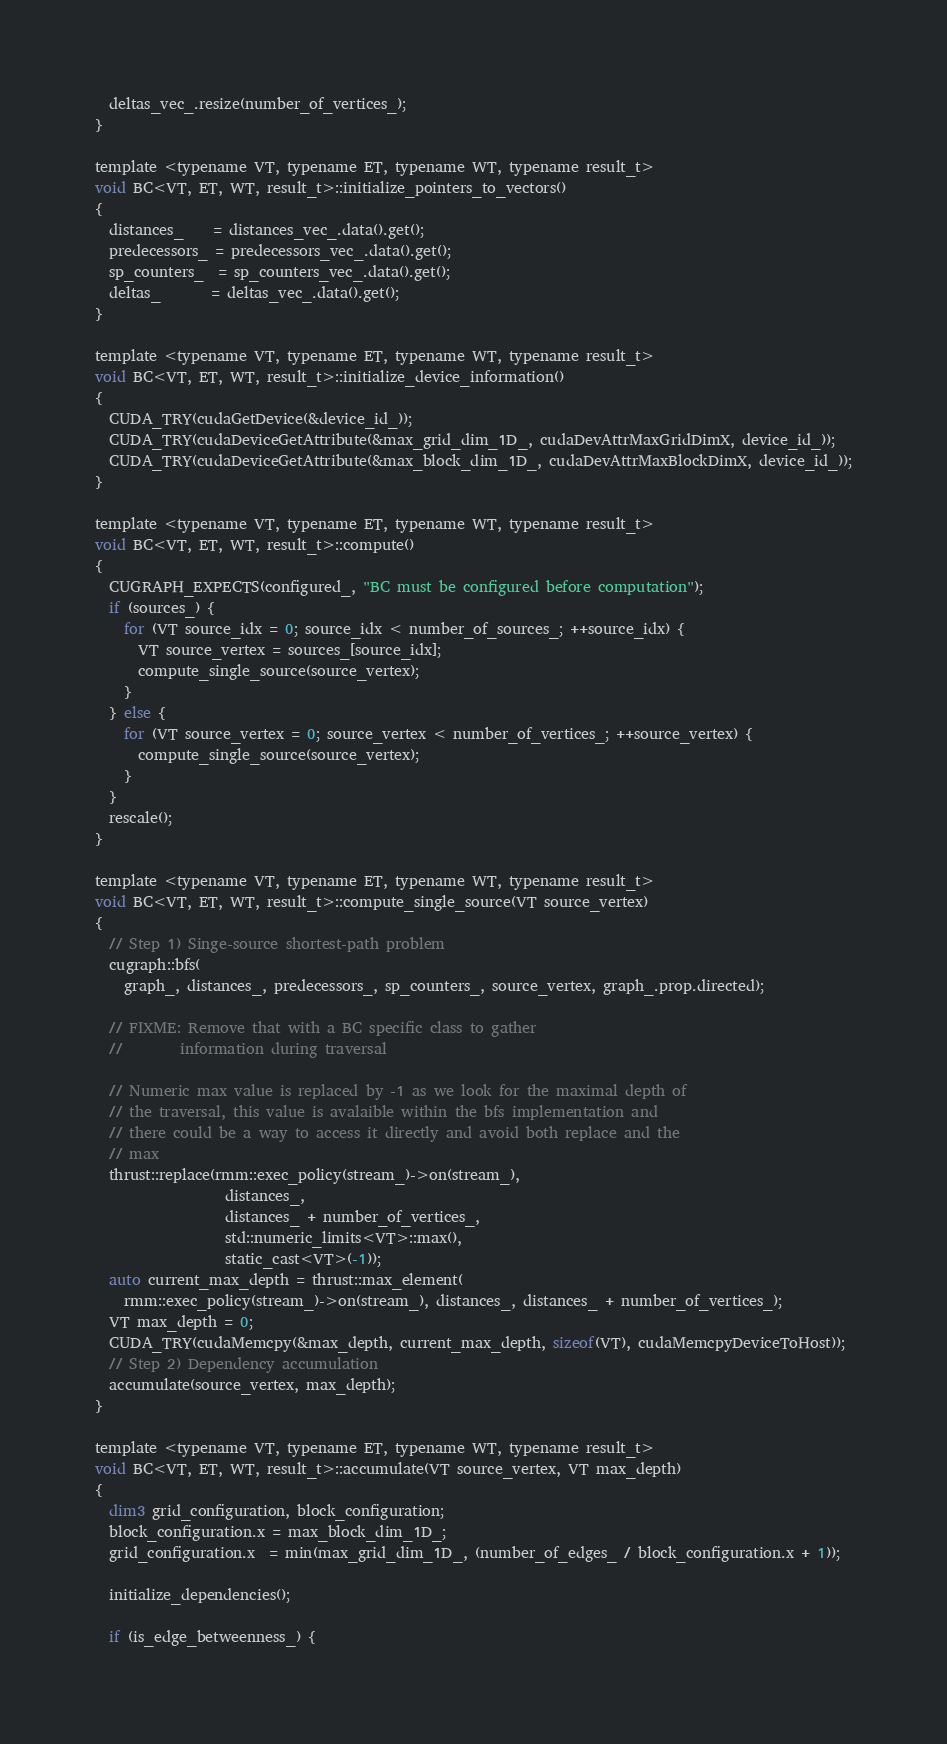<code> <loc_0><loc_0><loc_500><loc_500><_Cuda_>  deltas_vec_.resize(number_of_vertices_);
}

template <typename VT, typename ET, typename WT, typename result_t>
void BC<VT, ET, WT, result_t>::initialize_pointers_to_vectors()
{
  distances_    = distances_vec_.data().get();
  predecessors_ = predecessors_vec_.data().get();
  sp_counters_  = sp_counters_vec_.data().get();
  deltas_       = deltas_vec_.data().get();
}

template <typename VT, typename ET, typename WT, typename result_t>
void BC<VT, ET, WT, result_t>::initialize_device_information()
{
  CUDA_TRY(cudaGetDevice(&device_id_));
  CUDA_TRY(cudaDeviceGetAttribute(&max_grid_dim_1D_, cudaDevAttrMaxGridDimX, device_id_));
  CUDA_TRY(cudaDeviceGetAttribute(&max_block_dim_1D_, cudaDevAttrMaxBlockDimX, device_id_));
}

template <typename VT, typename ET, typename WT, typename result_t>
void BC<VT, ET, WT, result_t>::compute()
{
  CUGRAPH_EXPECTS(configured_, "BC must be configured before computation");
  if (sources_) {
    for (VT source_idx = 0; source_idx < number_of_sources_; ++source_idx) {
      VT source_vertex = sources_[source_idx];
      compute_single_source(source_vertex);
    }
  } else {
    for (VT source_vertex = 0; source_vertex < number_of_vertices_; ++source_vertex) {
      compute_single_source(source_vertex);
    }
  }
  rescale();
}

template <typename VT, typename ET, typename WT, typename result_t>
void BC<VT, ET, WT, result_t>::compute_single_source(VT source_vertex)
{
  // Step 1) Singe-source shortest-path problem
  cugraph::bfs(
    graph_, distances_, predecessors_, sp_counters_, source_vertex, graph_.prop.directed);

  // FIXME: Remove that with a BC specific class to gather
  //        information during traversal

  // Numeric max value is replaced by -1 as we look for the maximal depth of
  // the traversal, this value is avalaible within the bfs implementation and
  // there could be a way to access it directly and avoid both replace and the
  // max
  thrust::replace(rmm::exec_policy(stream_)->on(stream_),
                  distances_,
                  distances_ + number_of_vertices_,
                  std::numeric_limits<VT>::max(),
                  static_cast<VT>(-1));
  auto current_max_depth = thrust::max_element(
    rmm::exec_policy(stream_)->on(stream_), distances_, distances_ + number_of_vertices_);
  VT max_depth = 0;
  CUDA_TRY(cudaMemcpy(&max_depth, current_max_depth, sizeof(VT), cudaMemcpyDeviceToHost));
  // Step 2) Dependency accumulation
  accumulate(source_vertex, max_depth);
}

template <typename VT, typename ET, typename WT, typename result_t>
void BC<VT, ET, WT, result_t>::accumulate(VT source_vertex, VT max_depth)
{
  dim3 grid_configuration, block_configuration;
  block_configuration.x = max_block_dim_1D_;
  grid_configuration.x  = min(max_grid_dim_1D_, (number_of_edges_ / block_configuration.x + 1));

  initialize_dependencies();

  if (is_edge_betweenness_) {</code> 